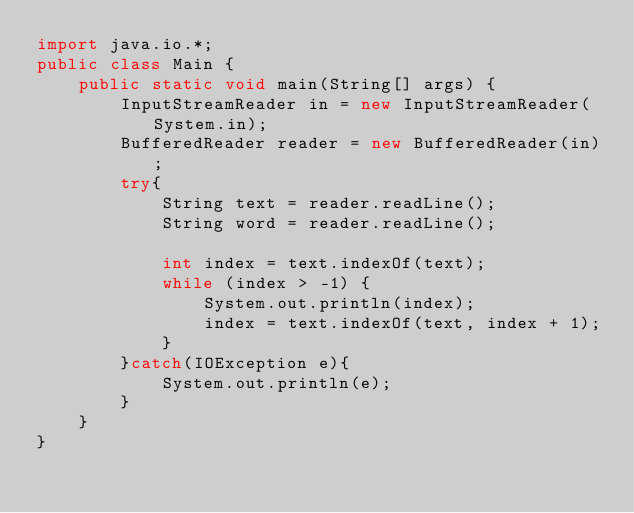Convert code to text. <code><loc_0><loc_0><loc_500><loc_500><_Java_>import java.io.*;
public class Main {
    public static void main(String[] args) {    
        InputStreamReader in = new InputStreamReader(System.in);
        BufferedReader reader = new BufferedReader(in);
        try{
            String text = reader.readLine();
            String word = reader.readLine();
            
            int index = text.indexOf(text);
            while (index > -1) {
            	System.out.println(index);
            	index = text.indexOf(text, index + 1);
            }
        }catch(IOException e){
            System.out.println(e);
        }  
    }
}</code> 